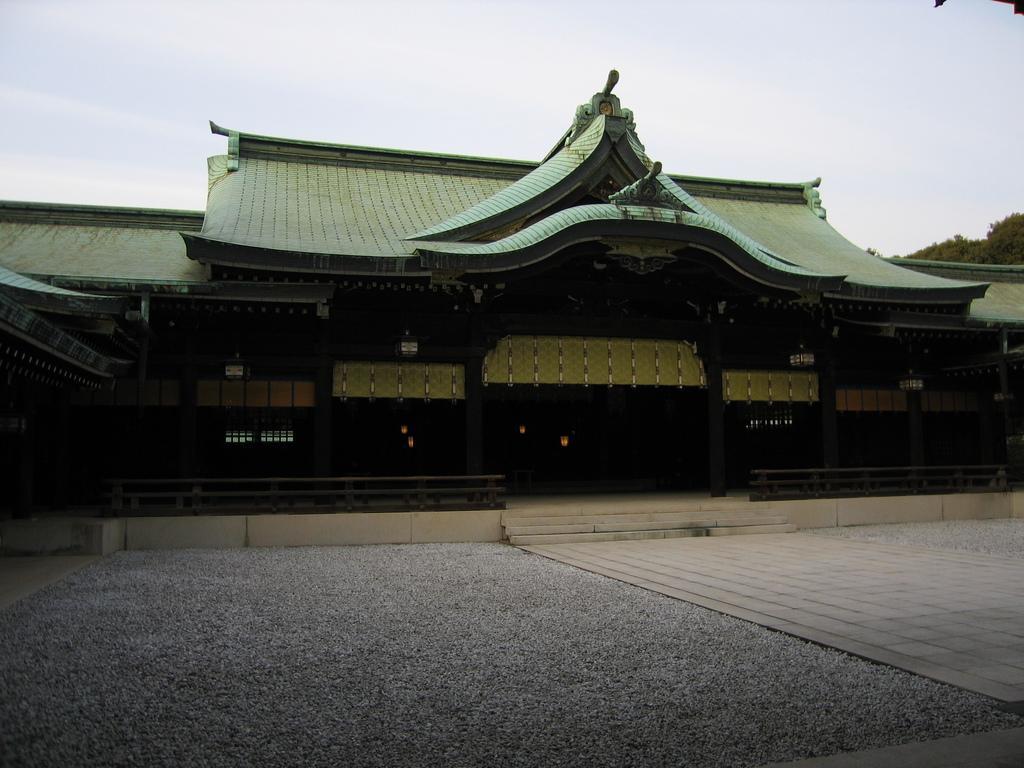Could you give a brief overview of what you see in this image? This picture is clicked outside. In the foreground we can see the ground and some stairs and we can see the railings and the house and we can see the windows of the house and some object seems to be the lights. In the background we can see the sky and the trees and we can see some other objects. 